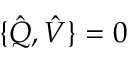Convert formula to latex. <formula><loc_0><loc_0><loc_500><loc_500>\{ \hat { Q } , \hat { V } \} = 0</formula> 